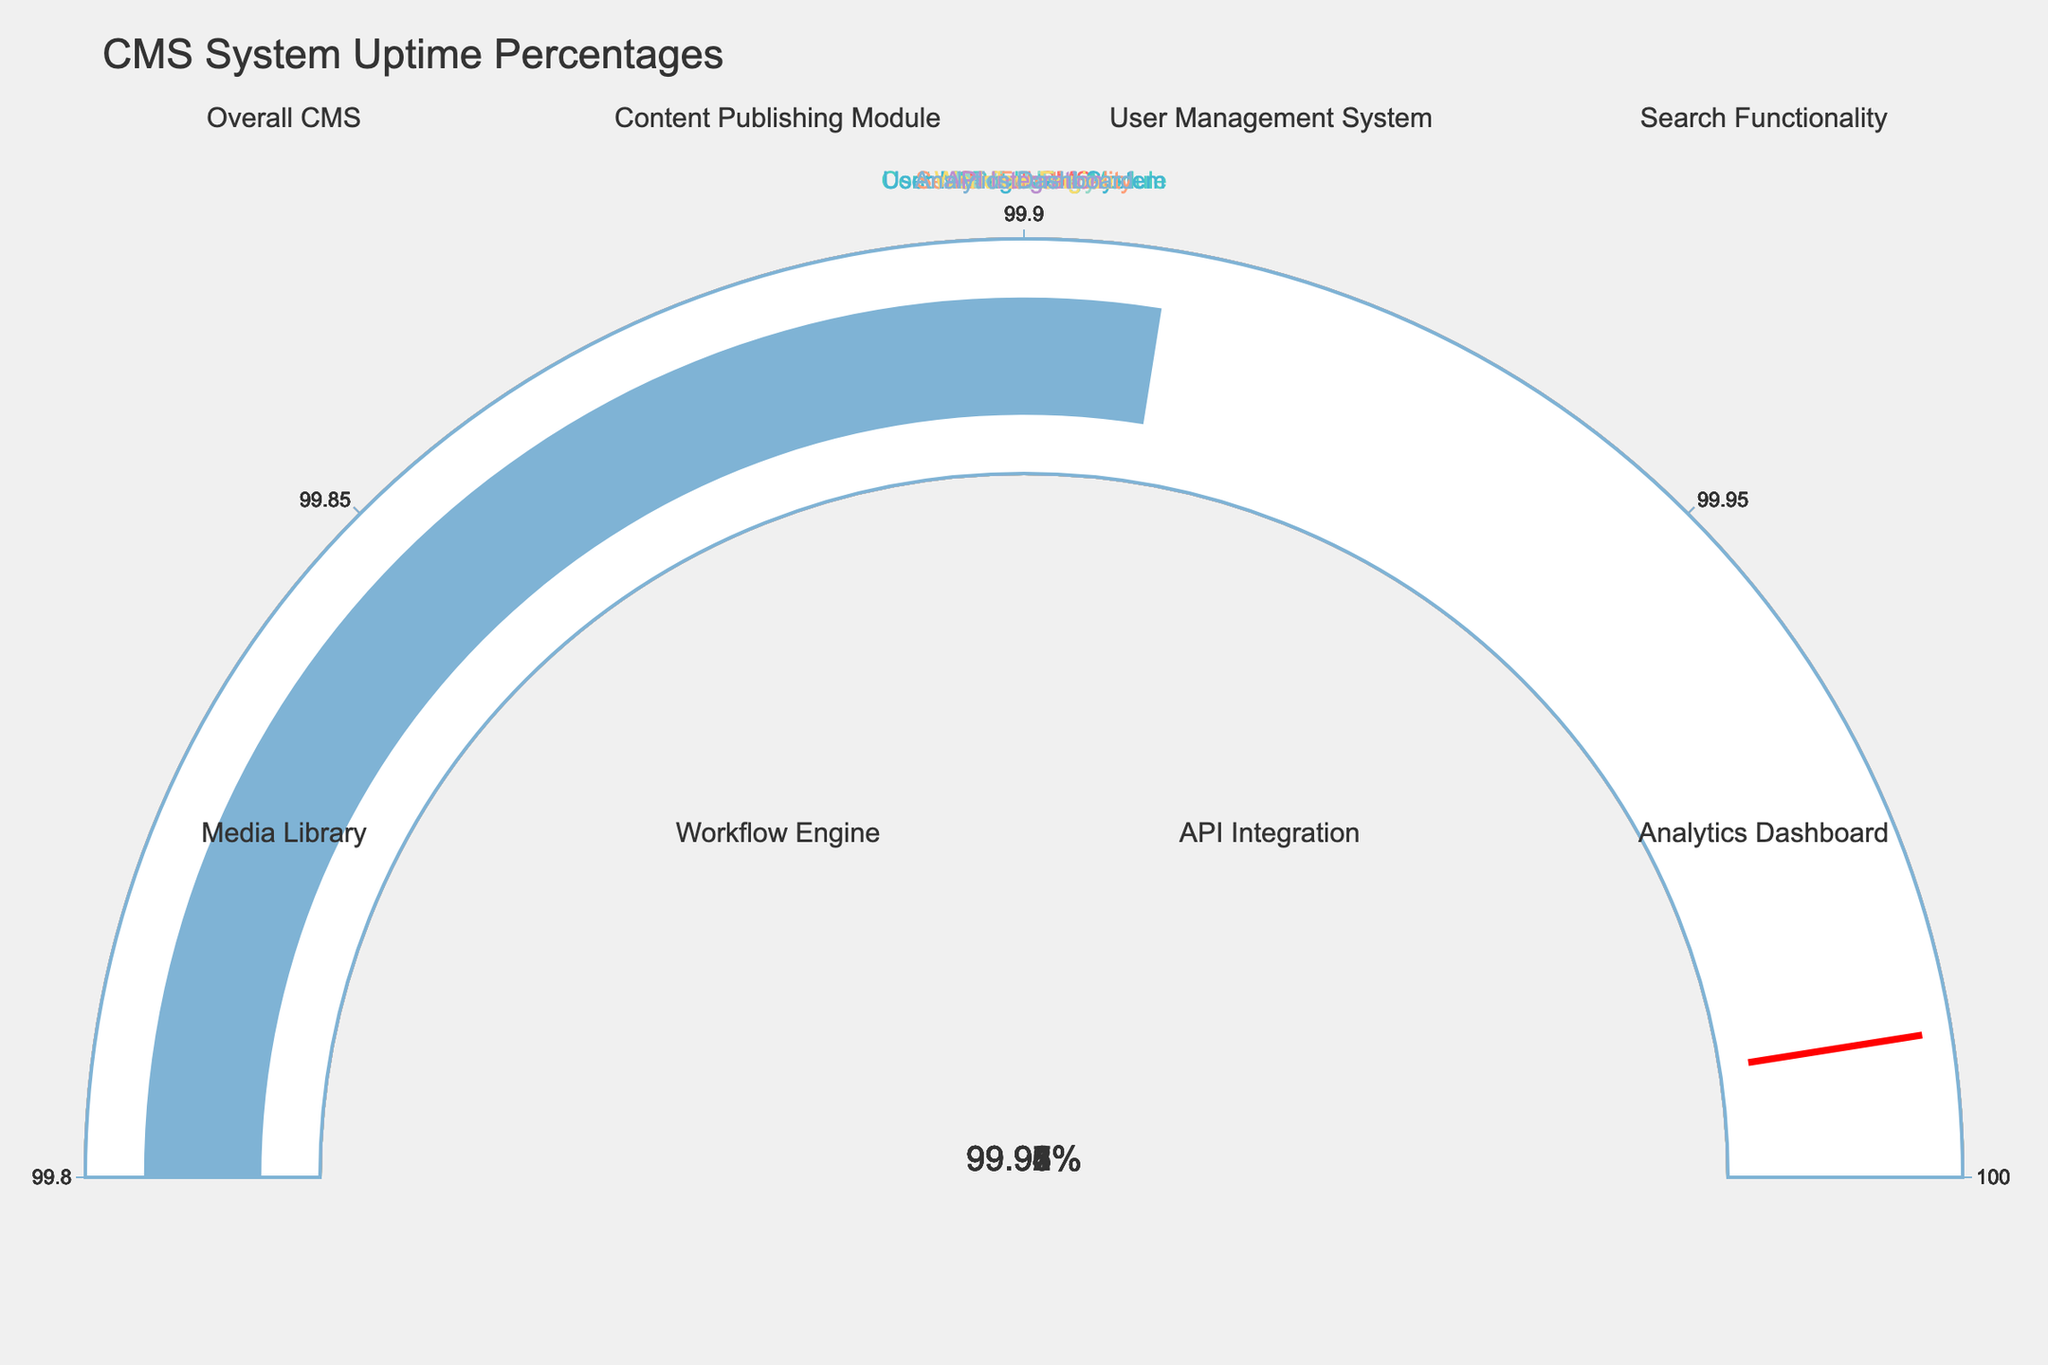What's the title of the figure? The title is located at the top center of the figure and reads "CMS System Uptime Percentages".
Answer: CMS System Uptime Percentages What is the lowest system uptime percentage shown in the gauges? By examining the percentage values displayed on each gauge, the lowest system uptime percentage is 99.91% (Analytics Dashboard).
Answer: 99.91% Which system has the highest uptime percentage? The highest uptime percentage displayed in the gauges is 99.98% for the Content Publishing Module.
Answer: Content Publishing Module What is the difference in uptime percentage between the API Integration and Media Library? API Integration has an uptime percentage of 99.92% and Media Library has 99.96%. The difference is calculated as 99.96% - 99.92% = 0.04%.
Answer: 0.04% What is the range of uptime percentages in the figure? The lowest uptime is 99.91% and the highest is 99.98%. The range is calculated as 99.98% - 99.91% = 0.07%.
Answer: 0.07% Which two systems have the closest uptime percentages? The Media Library (99.96%) and Search Functionality (99.97%) have the smallest difference in uptime percentage, which is 0.01%.
Answer: Media Library and Search Functionality What is the average uptime percentage of all systems? The sum of all uptime percentages is (99.95 + 99.98 + 99.93 + 99.97 + 99.96 + 99.94 + 99.92 + 99.91) = 799.56%. The average is 799.56% / 8 = 99.945%.
Answer: 99.945% How many systems have an uptime percentage equal to or greater than 99.95%? Counting the number of systems with an uptime percentage of 99.95% or higher, those are: Overall CMS (99.95%), Content Publishing Module (99.98%), Search Functionality (99.97%), Media Library (99.96%), and Workflow Engine (99.94%). There are 5 systems.
Answer: 5 systems Is there any system uptime percentage marked by a red line in the gauge? A red line is present in all gauges, indicating a threshold value of 99.99%. This red line is present irrespective of the actual system uptime percentage.
Answer: Yes How is the trend of uptime percentages distributed overall—are they mostly high or low? All system uptime percentages are highly clustered around the upper end of the range, from 99.91% to 99.98%, indicating overall high uptime performance for the CMS systems.
Answer: Mostly high 